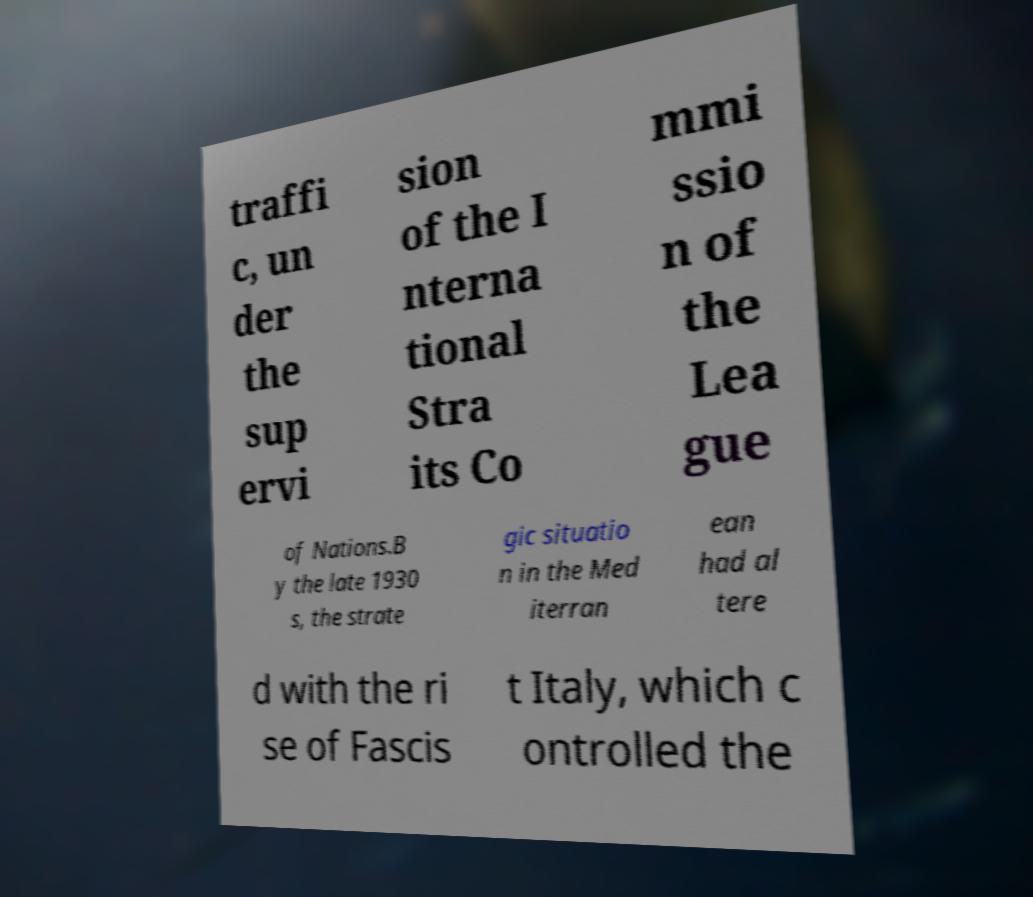Please identify and transcribe the text found in this image. traffi c, un der the sup ervi sion of the I nterna tional Stra its Co mmi ssio n of the Lea gue of Nations.B y the late 1930 s, the strate gic situatio n in the Med iterran ean had al tere d with the ri se of Fascis t Italy, which c ontrolled the 